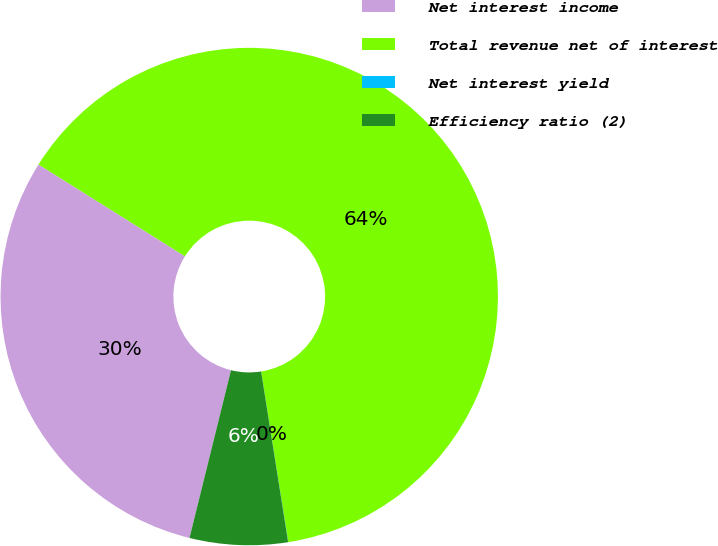Convert chart to OTSL. <chart><loc_0><loc_0><loc_500><loc_500><pie_chart><fcel>Net interest income<fcel>Total revenue net of interest<fcel>Net interest yield<fcel>Efficiency ratio (2)<nl><fcel>30.05%<fcel>63.58%<fcel>0.01%<fcel>6.36%<nl></chart> 